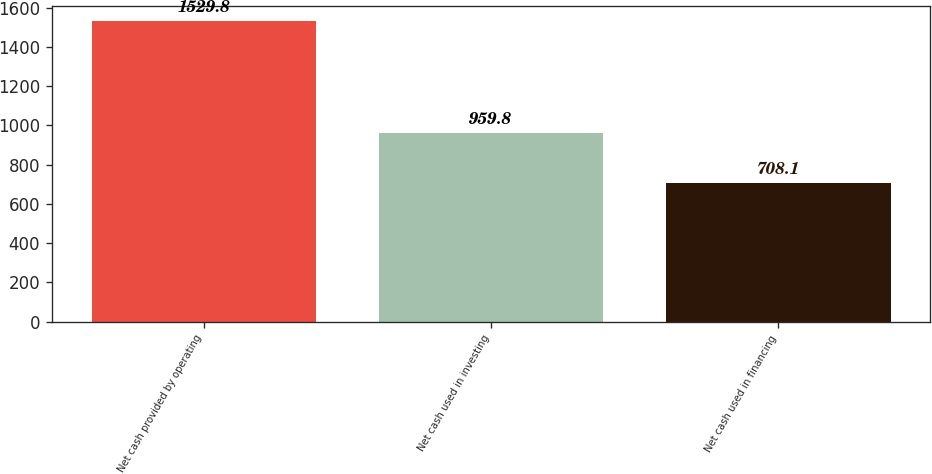Convert chart. <chart><loc_0><loc_0><loc_500><loc_500><bar_chart><fcel>Net cash provided by operating<fcel>Net cash used in investing<fcel>Net cash used in financing<nl><fcel>1529.8<fcel>959.8<fcel>708.1<nl></chart> 